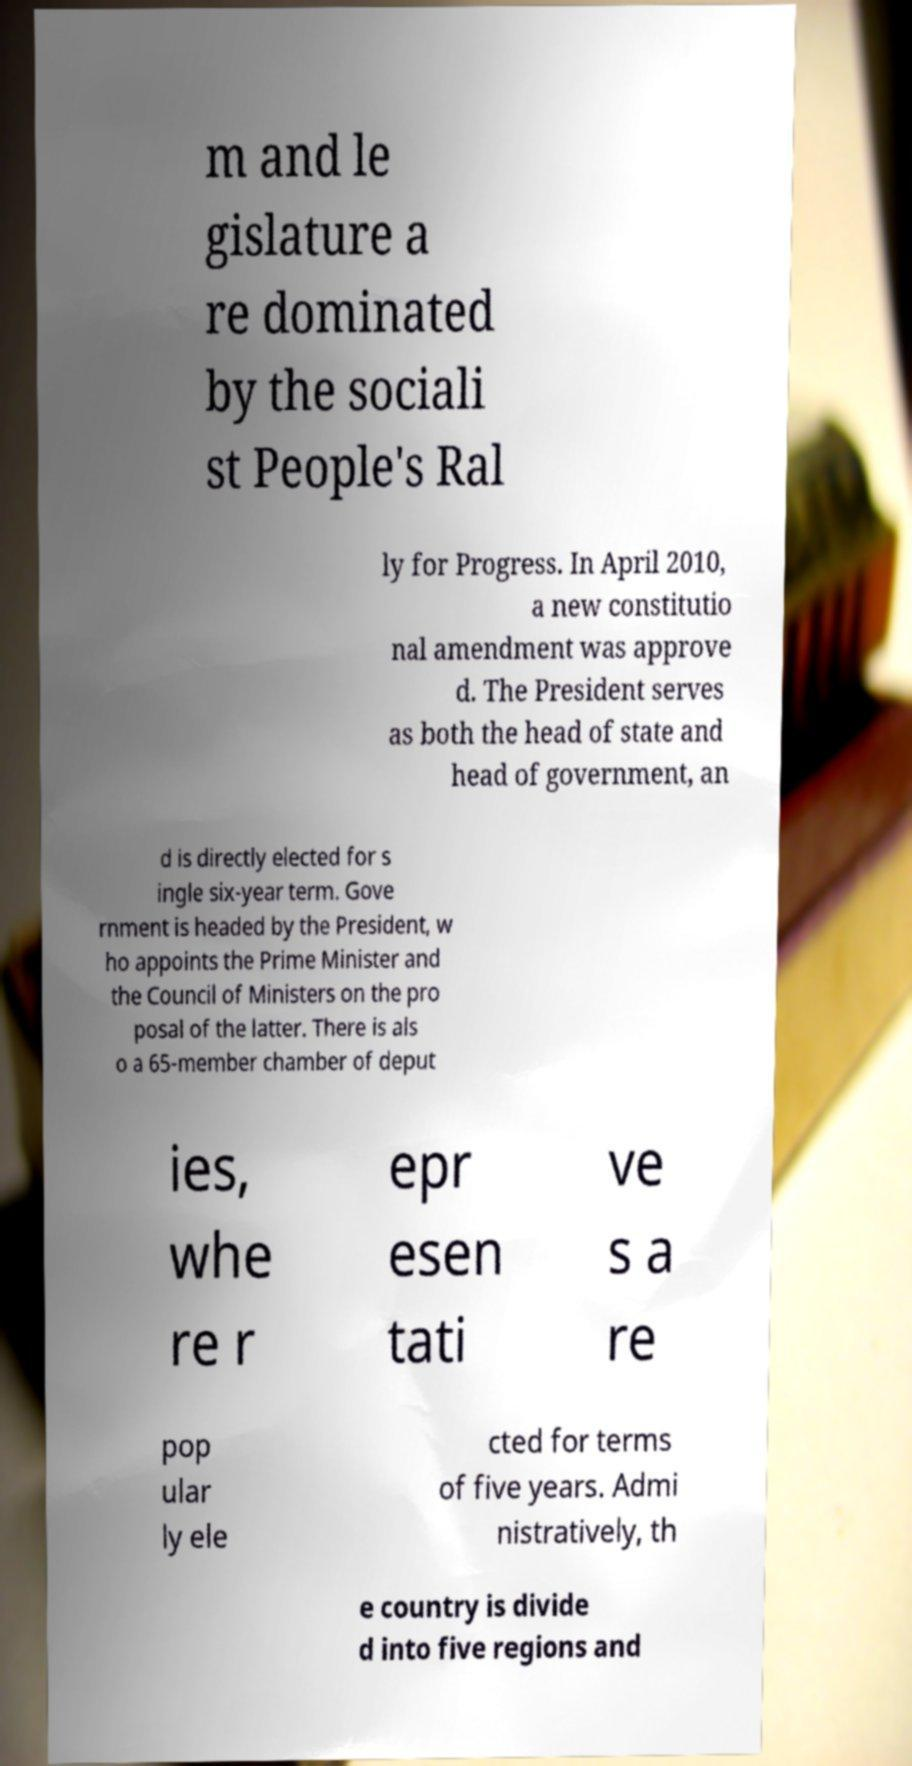I need the written content from this picture converted into text. Can you do that? m and le gislature a re dominated by the sociali st People's Ral ly for Progress. In April 2010, a new constitutio nal amendment was approve d. The President serves as both the head of state and head of government, an d is directly elected for s ingle six-year term. Gove rnment is headed by the President, w ho appoints the Prime Minister and the Council of Ministers on the pro posal of the latter. There is als o a 65-member chamber of deput ies, whe re r epr esen tati ve s a re pop ular ly ele cted for terms of five years. Admi nistratively, th e country is divide d into five regions and 